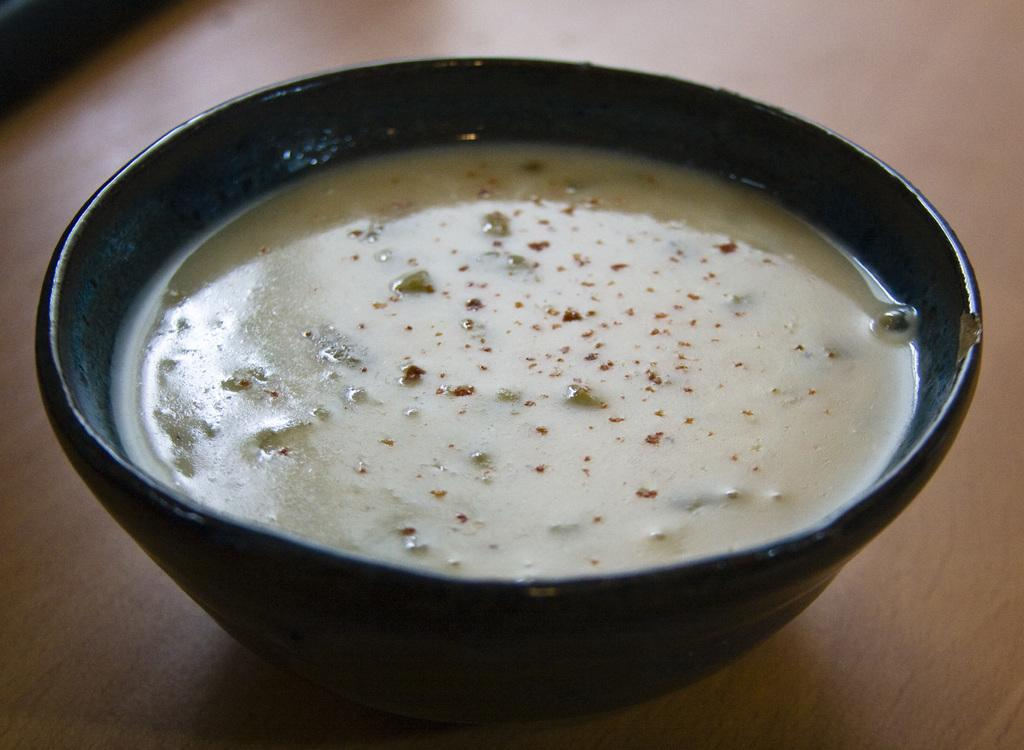What is in the bowl that is visible in the image? There is food in a bowl in the image. Where is the bowl located in the image? The bowl is on a platform. What type of vein can be seen in the image? There is no vein present in the image. What fictional character might be associated with the food in the image? The image does not depict any specific fictional characters, so it cannot be determined which character might be associated with the food. 